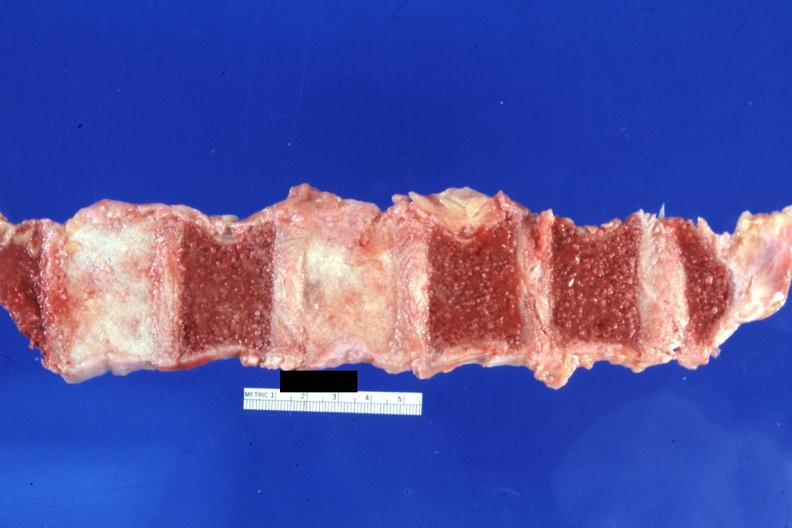what do not have history at this time diagnosis?
Answer the question using a single word or phrase. Typical ivory vertebra 